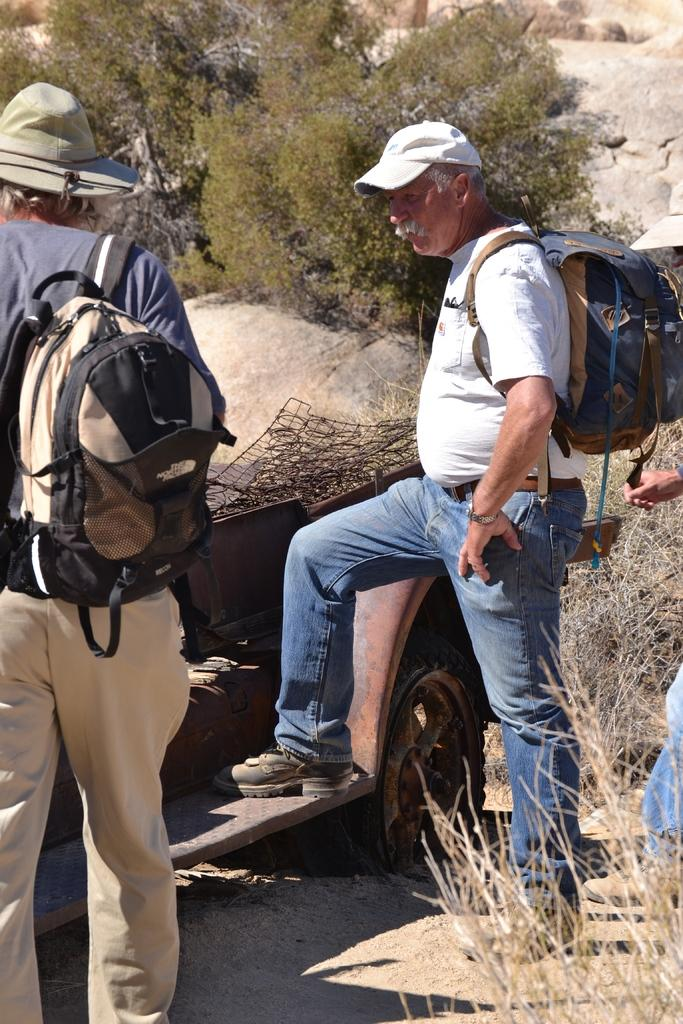How many people are in the image? There are two men in the image. What are the men carrying on their backs? The men are carrying backpacks. What type of headwear are the men wearing? The men are wearing caps. What type of vegetation can be seen in the image? There are trees visible in the image. What type of material is present in the image? The image contains stone. Can you see a goat or a kitten playing with a box in the image? No, there is no goat, kitten, or box present in the image. 